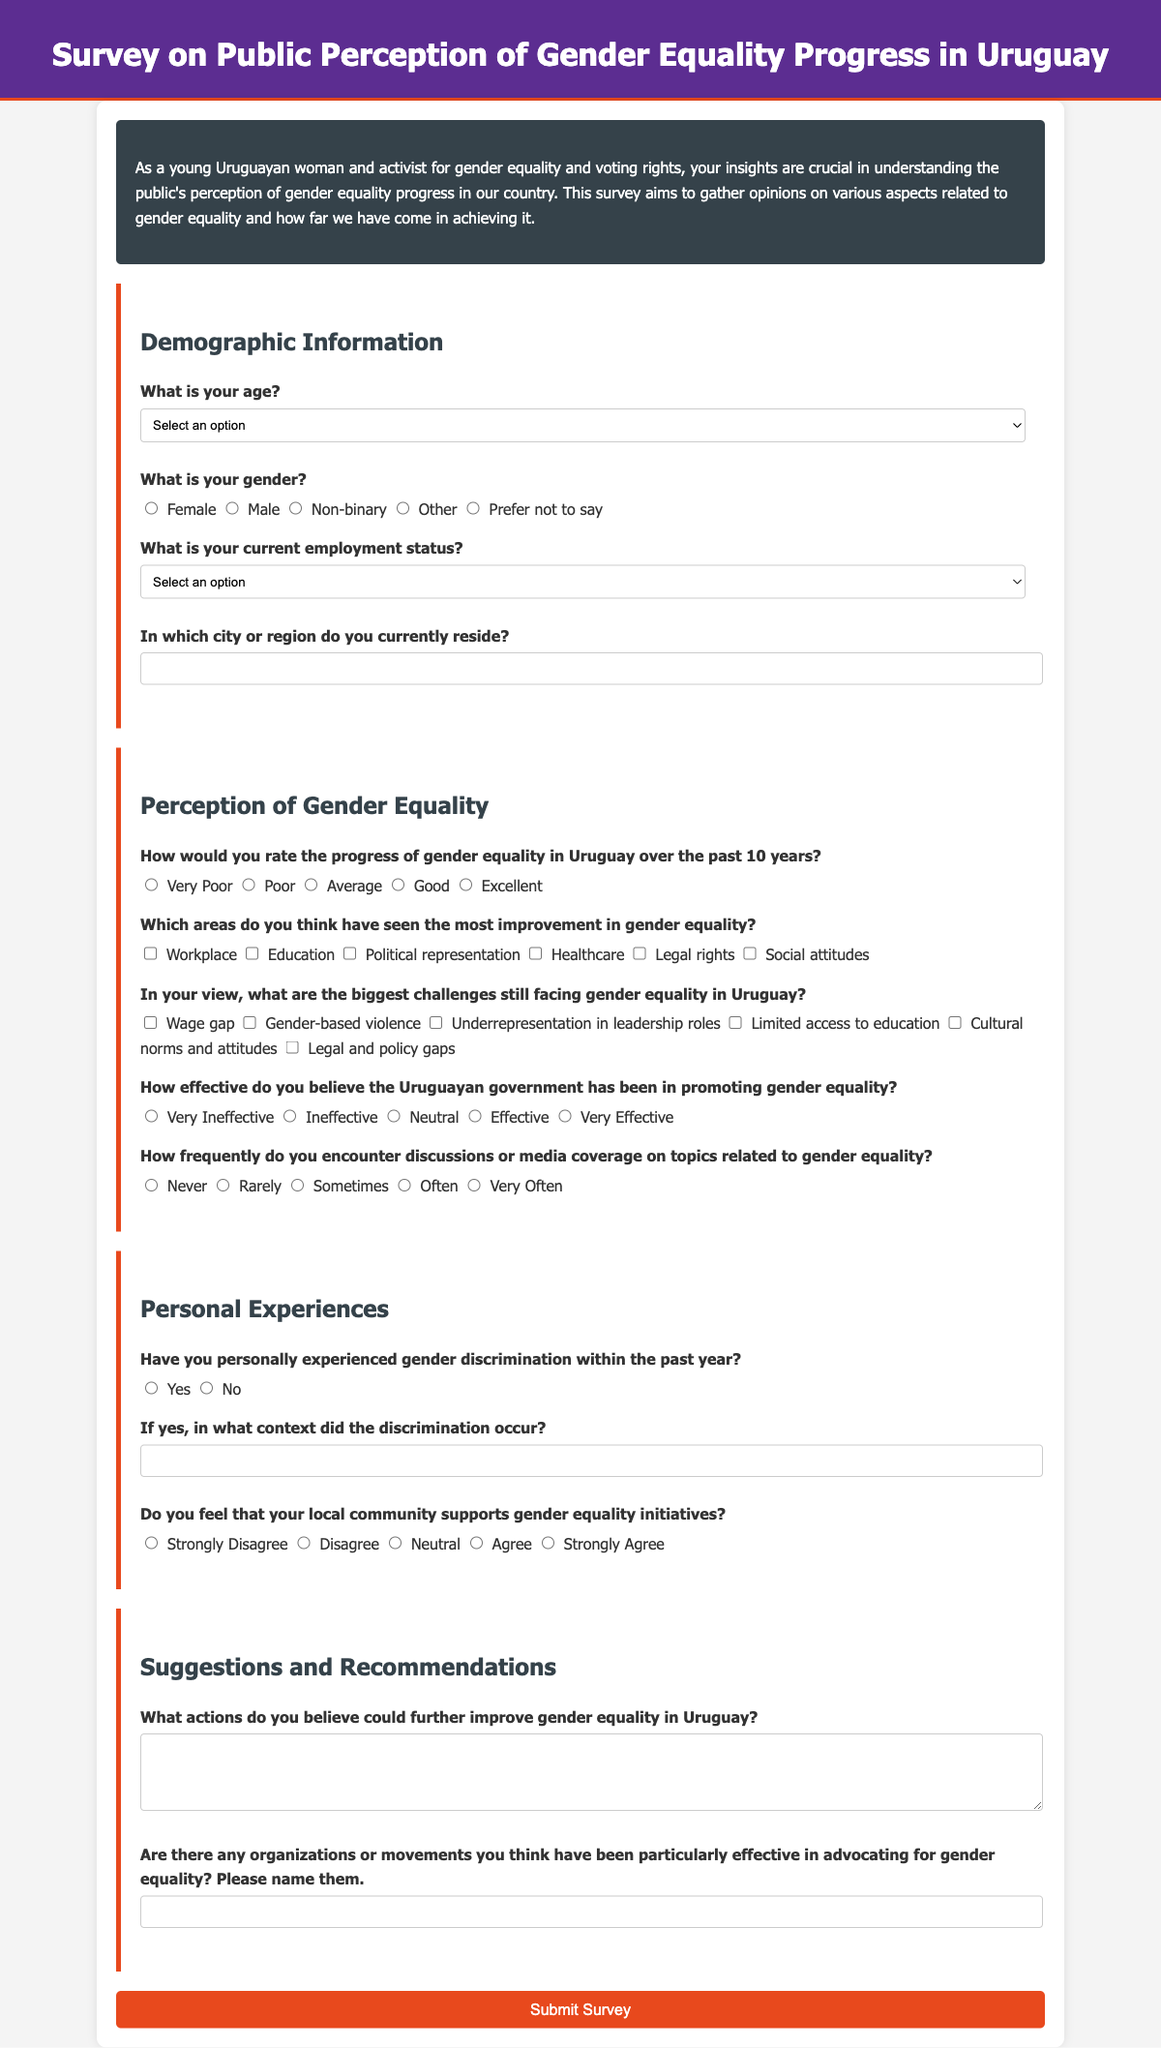What is the title of the survey? The title of the survey is provided in the header of the document.
Answer: Survey on Public Perception of Gender Equality Progress in Uruguay What is the purpose of the survey? The purpose is stated in the introductory paragraph of the document.
Answer: To gather opinions on various aspects related to gender equality How many areas for improvement in gender equality are listed in the survey? The survey lists areas that have seen improvement; counting them provides the total.
Answer: 6 What age group has the option "Under 18" in the survey? The age options presented determine the specific groups available for selection.
Answer: Age What is the maximum rating for the effectiveness of the Uruguayan government? The effectiveness rating scale shows the range from very ineffective to very effective, indicating maximum.
Answer: 5 In which section do participants provide their suggestions for improving gender equality? The section titles indicate where suggestions can be made, leading to the relevant area in the document.
Answer: Suggestions and Recommendations How does the survey categorize personal experiences of gender discrimination? The survey asks a direct yes/no question to identify personal experiences.
Answer: Yes or No Which employment status options are provided in the survey? The survey outlines specific employment status choices that participants can select from.
Answer: 7 What color is used for the header background? The header background color is specified in the style section of the document.
Answer: Dark purple 